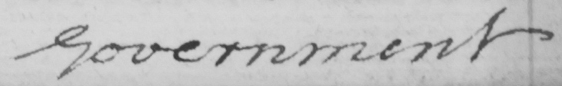Can you tell me what this handwritten text says? Government 